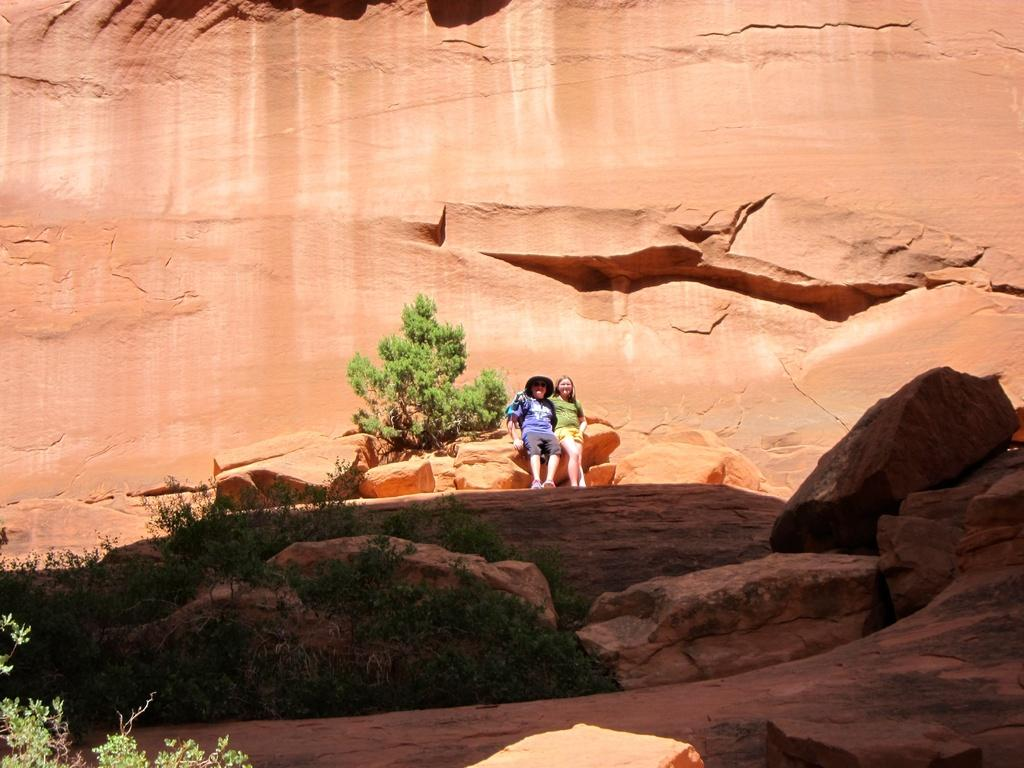How many people are in the image? There are two persons in the image. Can you describe the clothing of one of the persons? One of the persons is wearing a hat. What type of natural elements can be seen in the image? There are rocks and plants visible in the image. What type of straw is being used by the person in the image? There is no straw present in the image. 